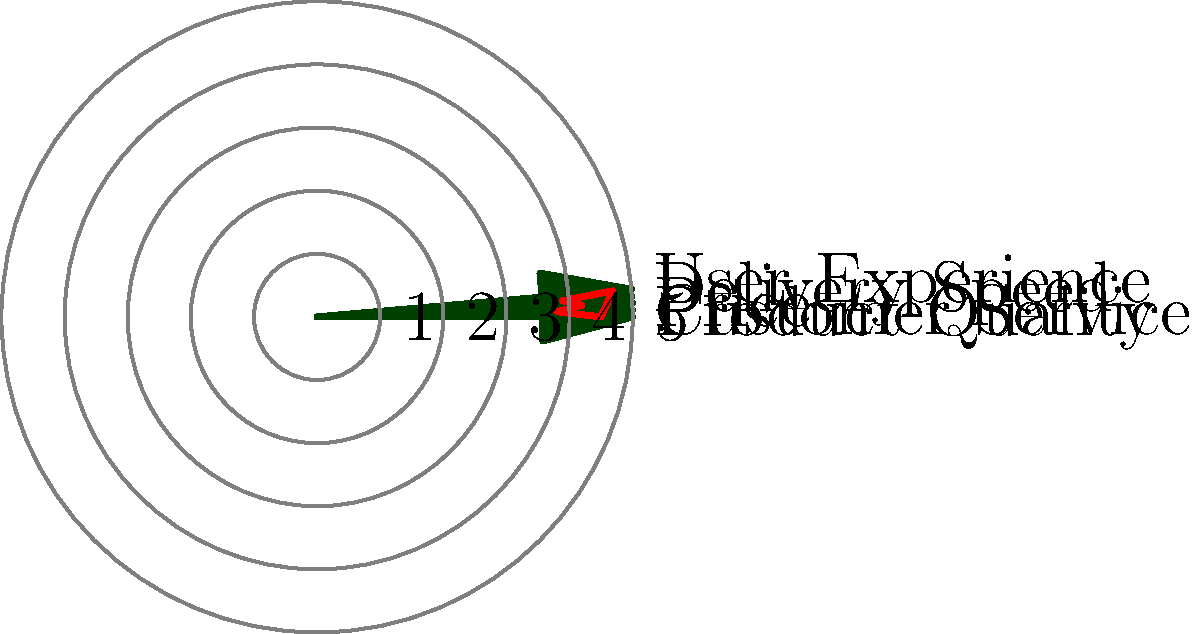As a business owner, you've conducted a customer satisfaction survey for your company's services. The results are plotted on a star plot, where each axis represents a different aspect of service quality, scaled from 0 to 5. Given the plot, which aspect of your business has received the highest rating, and what is its approximate value? To answer this question, we need to analyze the star plot systematically:

1. Identify all aspects represented in the plot:
   - Product Quality
   - Customer Service
   - Price
   - Delivery Speed
   - User Experience

2. Observe the scale:
   - The plot is divided into 5 concentric circles, representing ratings from 1 to 5.

3. Examine each axis:
   - Product Quality: approximately 4.5
   - Customer Service: approximately 3.8
   - Price: approximately 4.2
   - Delivery Speed: approximately 3.9
   - User Experience: extends beyond the 4th circle, close to the outermost circle

4. Compare the ratings:
   - User Experience clearly extends the furthest from the center, indicating the highest rating.

5. Estimate the value for User Experience:
   - It's slightly below the outermost circle (5), but well above the 4th circle.
   - A reasonable estimate would be approximately 4.7.

Therefore, User Experience has received the highest rating, with an approximate value of 4.7 out of 5.
Answer: User Experience, approximately 4.7 